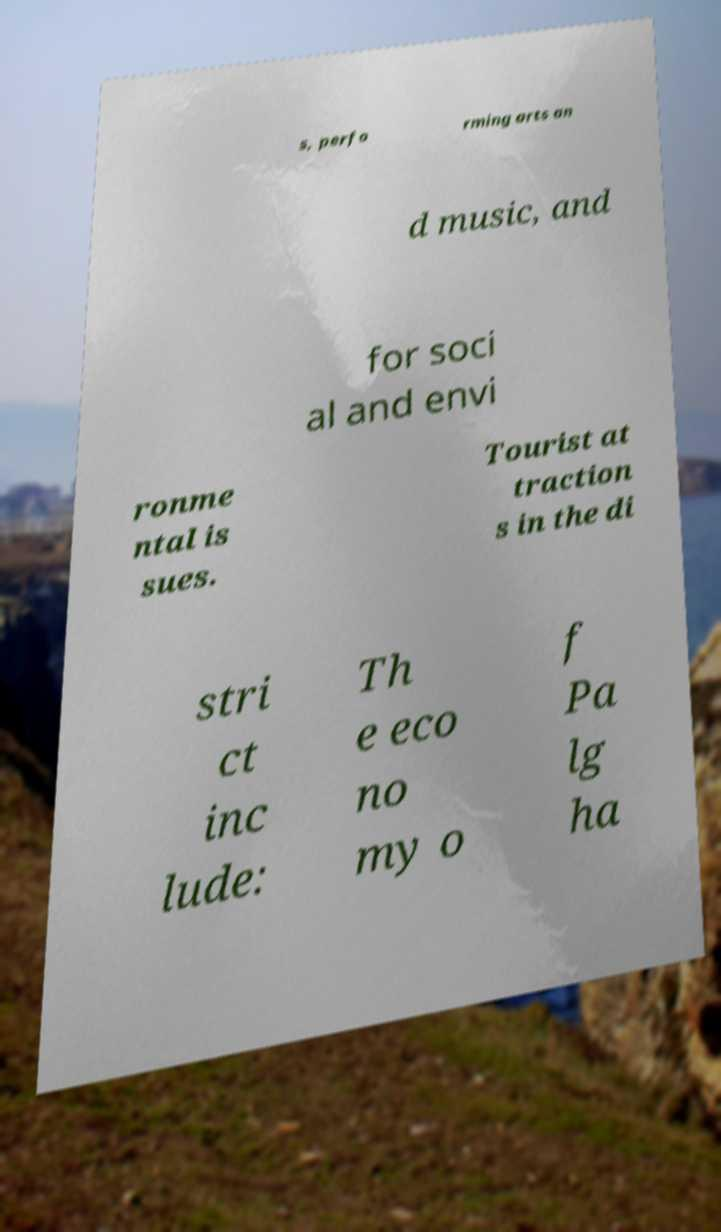I need the written content from this picture converted into text. Can you do that? s, perfo rming arts an d music, and for soci al and envi ronme ntal is sues. Tourist at traction s in the di stri ct inc lude: Th e eco no my o f Pa lg ha 